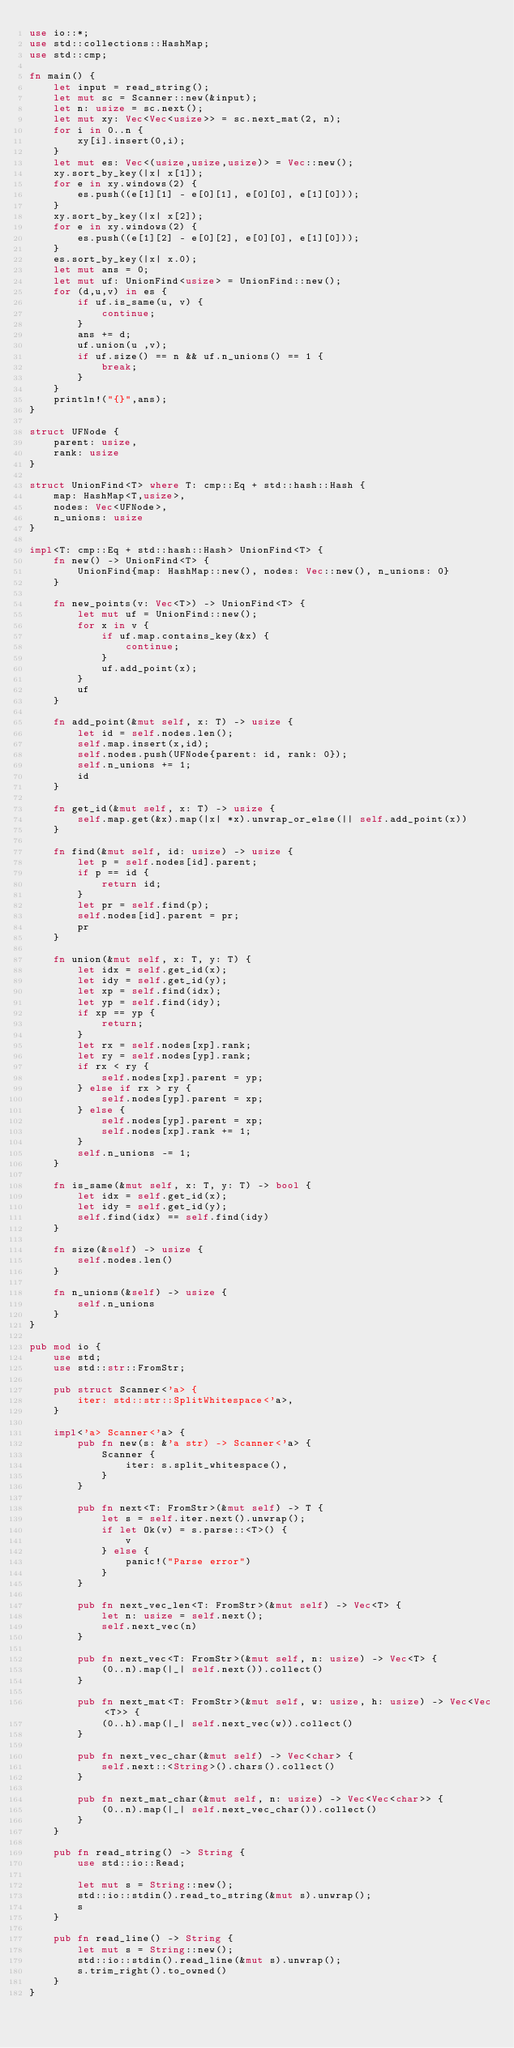Convert code to text. <code><loc_0><loc_0><loc_500><loc_500><_Rust_>use io::*;
use std::collections::HashMap;
use std::cmp;

fn main() {
    let input = read_string();
    let mut sc = Scanner::new(&input);
    let n: usize = sc.next();
    let mut xy: Vec<Vec<usize>> = sc.next_mat(2, n);
    for i in 0..n {
        xy[i].insert(0,i);
    }
    let mut es: Vec<(usize,usize,usize)> = Vec::new();
    xy.sort_by_key(|x| x[1]);
    for e in xy.windows(2) {
        es.push((e[1][1] - e[0][1], e[0][0], e[1][0]));
    }
    xy.sort_by_key(|x| x[2]);
    for e in xy.windows(2) {
        es.push((e[1][2] - e[0][2], e[0][0], e[1][0]));
    }
    es.sort_by_key(|x| x.0);
    let mut ans = 0;
    let mut uf: UnionFind<usize> = UnionFind::new();
    for (d,u,v) in es {
        if uf.is_same(u, v) {
            continue;
        }
        ans += d;
        uf.union(u ,v);
        if uf.size() == n && uf.n_unions() == 1 {
            break;
        }
    }
    println!("{}",ans);
}

struct UFNode {
    parent: usize,
    rank: usize
}

struct UnionFind<T> where T: cmp::Eq + std::hash::Hash {
    map: HashMap<T,usize>,
    nodes: Vec<UFNode>,
    n_unions: usize
}

impl<T: cmp::Eq + std::hash::Hash> UnionFind<T> {
    fn new() -> UnionFind<T> {
        UnionFind{map: HashMap::new(), nodes: Vec::new(), n_unions: 0}
    }

    fn new_points(v: Vec<T>) -> UnionFind<T> {
        let mut uf = UnionFind::new();
        for x in v {
            if uf.map.contains_key(&x) {
                continue;
            }
            uf.add_point(x);
        }
        uf
    }

    fn add_point(&mut self, x: T) -> usize {
        let id = self.nodes.len();
        self.map.insert(x,id);
        self.nodes.push(UFNode{parent: id, rank: 0});
        self.n_unions += 1;
        id
    }

    fn get_id(&mut self, x: T) -> usize {
        self.map.get(&x).map(|x| *x).unwrap_or_else(|| self.add_point(x))
    }

    fn find(&mut self, id: usize) -> usize {
        let p = self.nodes[id].parent;
        if p == id {
            return id;
        }
        let pr = self.find(p);
        self.nodes[id].parent = pr;
        pr
    }

    fn union(&mut self, x: T, y: T) {
        let idx = self.get_id(x);
        let idy = self.get_id(y);
        let xp = self.find(idx);
        let yp = self.find(idy);
        if xp == yp {
            return;
        }
        let rx = self.nodes[xp].rank;
        let ry = self.nodes[yp].rank;
        if rx < ry {
            self.nodes[xp].parent = yp;
        } else if rx > ry {
            self.nodes[yp].parent = xp;
        } else {
            self.nodes[yp].parent = xp;
            self.nodes[xp].rank += 1;
        }
        self.n_unions -= 1;
    }

    fn is_same(&mut self, x: T, y: T) -> bool {
        let idx = self.get_id(x);
        let idy = self.get_id(y);
        self.find(idx) == self.find(idy)
    }

    fn size(&self) -> usize {
        self.nodes.len()
    }

    fn n_unions(&self) -> usize {
        self.n_unions
    }
}

pub mod io {
    use std;
    use std::str::FromStr;

    pub struct Scanner<'a> {
        iter: std::str::SplitWhitespace<'a>,
    }

    impl<'a> Scanner<'a> {
        pub fn new(s: &'a str) -> Scanner<'a> {
            Scanner {
                iter: s.split_whitespace(),
            }
        }

        pub fn next<T: FromStr>(&mut self) -> T {
            let s = self.iter.next().unwrap();
            if let Ok(v) = s.parse::<T>() {
                v
            } else {
                panic!("Parse error")
            }
        }

        pub fn next_vec_len<T: FromStr>(&mut self) -> Vec<T> {
            let n: usize = self.next();
            self.next_vec(n)
        }

        pub fn next_vec<T: FromStr>(&mut self, n: usize) -> Vec<T> {
            (0..n).map(|_| self.next()).collect()
        }

        pub fn next_mat<T: FromStr>(&mut self, w: usize, h: usize) -> Vec<Vec<T>> {
            (0..h).map(|_| self.next_vec(w)).collect()
        }

        pub fn next_vec_char(&mut self) -> Vec<char> {
            self.next::<String>().chars().collect()
        }

        pub fn next_mat_char(&mut self, n: usize) -> Vec<Vec<char>> {
            (0..n).map(|_| self.next_vec_char()).collect()
        }
    }

    pub fn read_string() -> String {
        use std::io::Read;

        let mut s = String::new();
        std::io::stdin().read_to_string(&mut s).unwrap();
        s
    }

    pub fn read_line() -> String {
        let mut s = String::new();
        std::io::stdin().read_line(&mut s).unwrap();
        s.trim_right().to_owned()
    }
}
</code> 